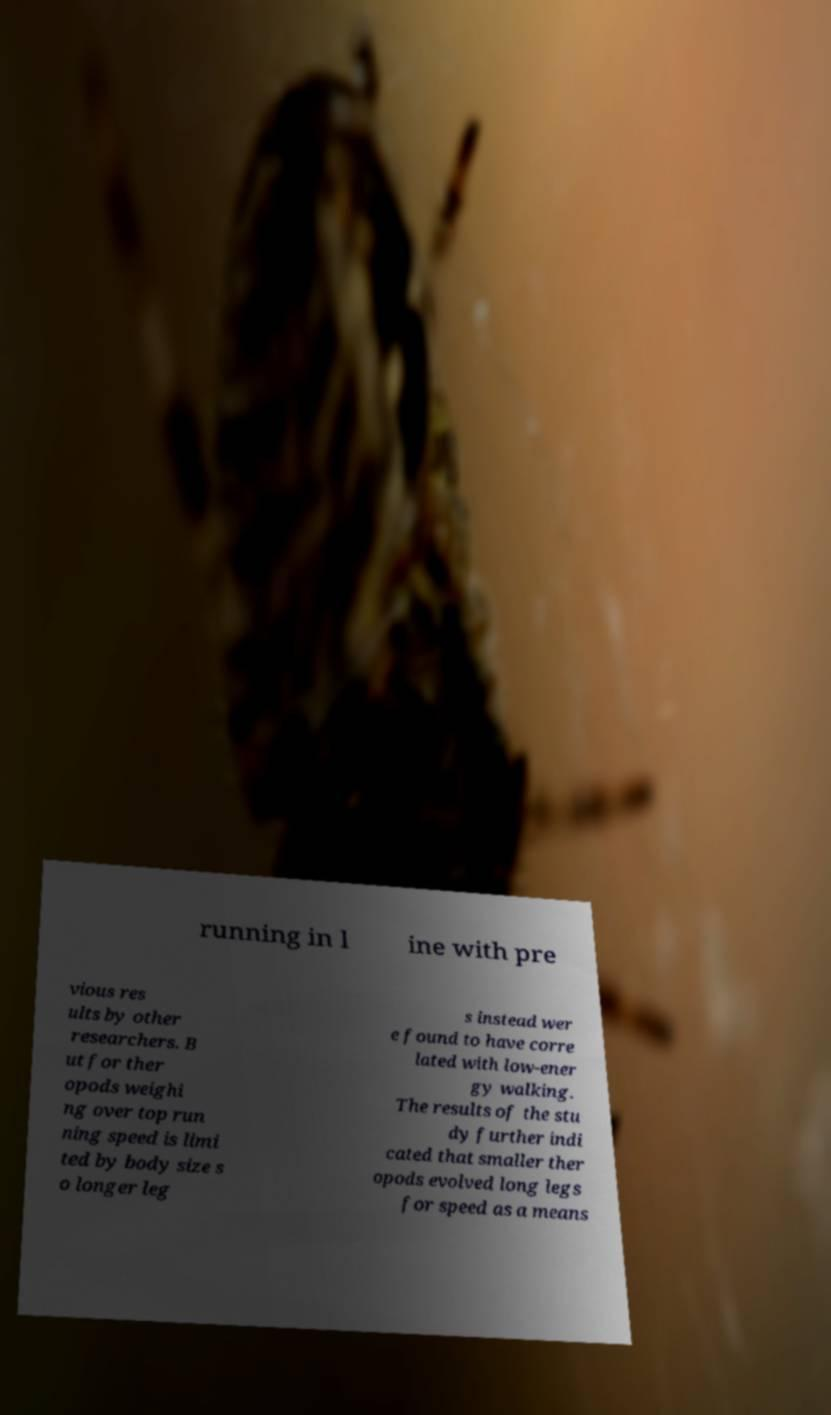Could you extract and type out the text from this image? running in l ine with pre vious res ults by other researchers. B ut for ther opods weighi ng over top run ning speed is limi ted by body size s o longer leg s instead wer e found to have corre lated with low-ener gy walking. The results of the stu dy further indi cated that smaller ther opods evolved long legs for speed as a means 